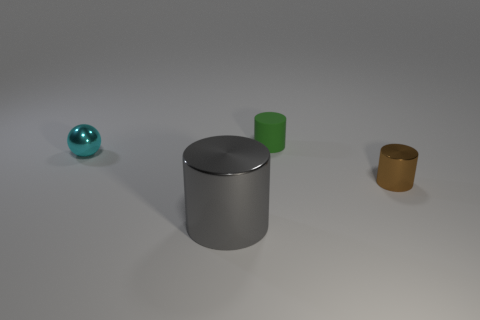What number of objects are brown objects or objects that are right of the tiny rubber cylinder?
Make the answer very short. 1. There is a tiny shiny thing that is behind the brown thing; is it the same shape as the shiny thing in front of the tiny brown cylinder?
Give a very brief answer. No. Is there anything else that is the same color as the matte cylinder?
Keep it short and to the point. No. The other small thing that is the same material as the tiny cyan object is what shape?
Your response must be concise. Cylinder. What is the thing that is behind the big gray thing and in front of the tiny cyan thing made of?
Provide a succinct answer. Metal. Is there any other thing that is the same size as the gray object?
Offer a very short reply. No. What number of red matte objects are the same shape as the green object?
Your answer should be very brief. 0. What size is the brown cylinder that is made of the same material as the small cyan sphere?
Provide a short and direct response. Small. Does the cyan object have the same size as the gray metallic thing?
Keep it short and to the point. No. Are any small blue metal balls visible?
Keep it short and to the point. No. 